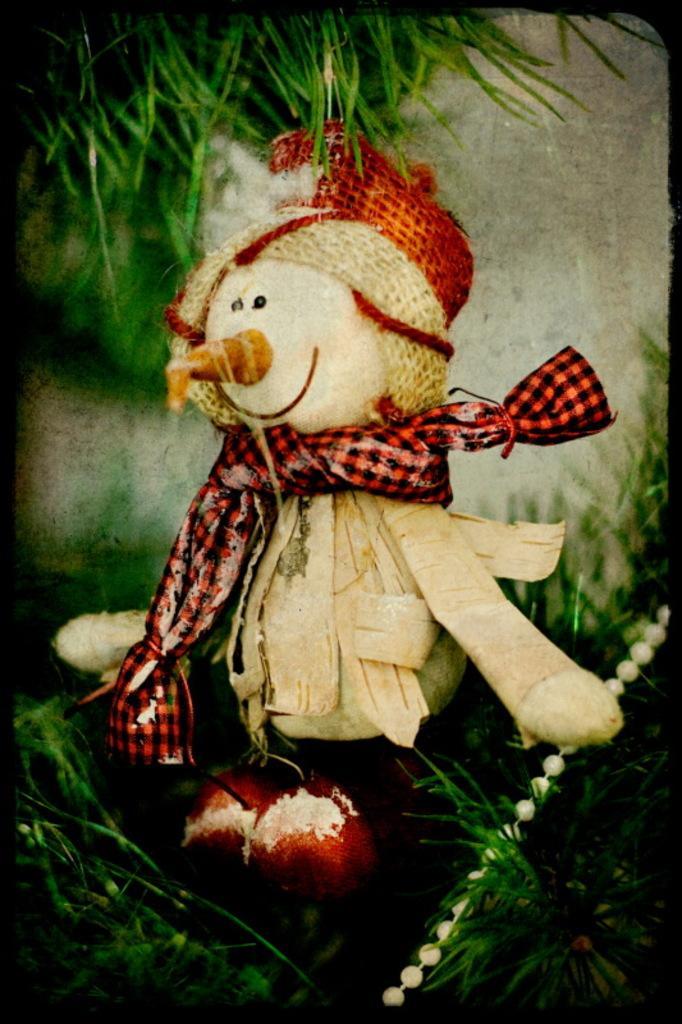Please provide a concise description of this image. Here we can see a toy and this is grass. 